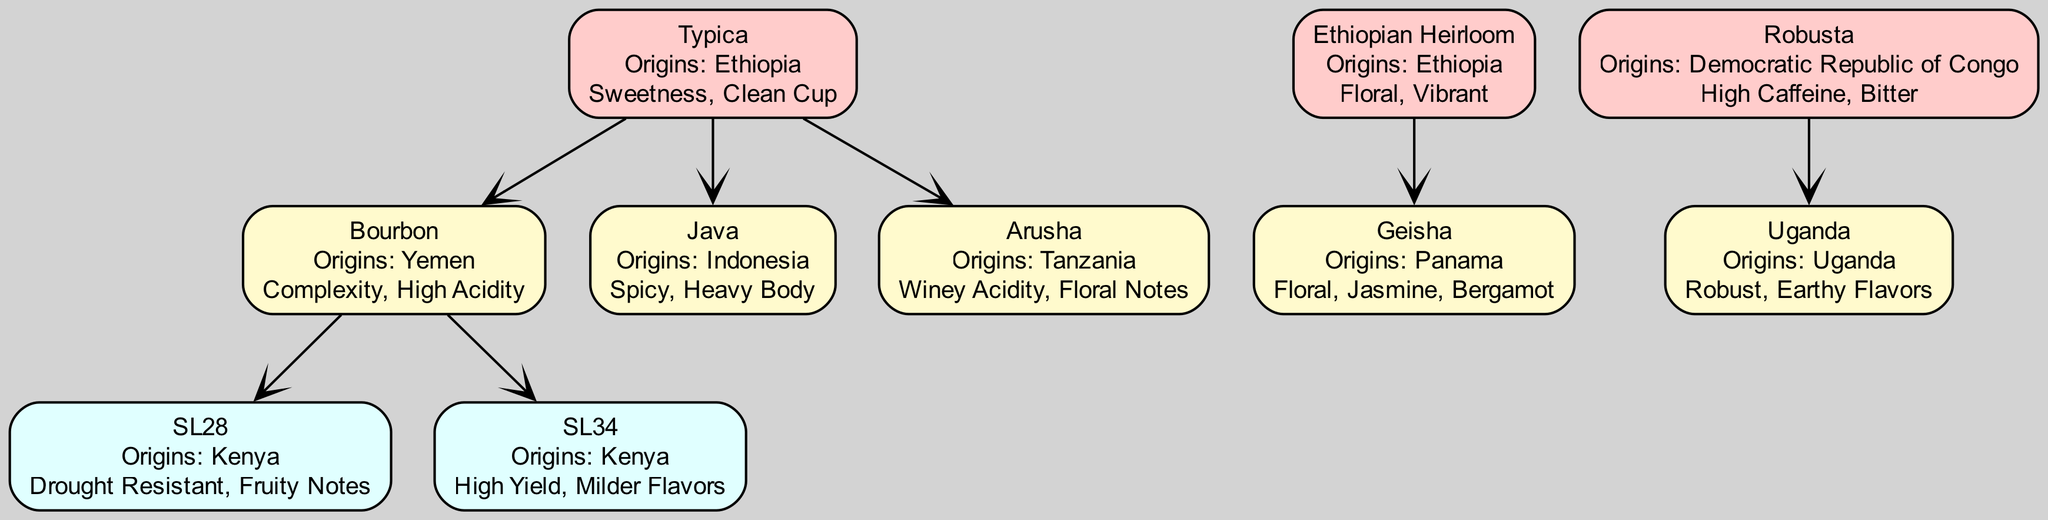What are the origins of Typica? The diagram indicates that Typica has its origins in Ethiopia, as specified directly in its node label.
Answer: Ethiopia How many descendants does Bourbon have? Looking at the Bourbon node in the diagram, it lists two descendants: SL28 and SL34, making the count of descendants two.
Answer: 2 What characteristics are associated with Geisha? The Geisha node provides specific characteristics: Floral, Jasmine, and Bergamot, which are directly described in its label.
Answer: Floral, Jasmine, Bergamot Which varietal descends from Ethiopian Heirloom? The diagram shows that the sole descendant of Ethiopian Heirloom is Geisha, indicated clearly in its branching structure.
Answer: Geisha What is the primary origin of Robusta? In the diagram, Robusta's origin is specified as being the Democratic Republic of Congo, which is shown in its corresponding node.
Answer: Democratic Republic of Congo Which varietal has the characteristic of "Drought Resistant"? The SL28 node specifically mentions Drought Resistant as one of its characteristics, allowing us to identify SL28 directly as the answer.
Answer: SL28 How many main groups of coffee varietals are depicted in the diagram? By examining the top-level nodes under 'Coffee Bean Varietals', there are three groups: Typica, Ethiopian Heirloom, and Robusta, which gives a total of three main groups.
Answer: 3 What characteristic differentiates Java from other varietals under Typica? Java is defined by its unique characteristic of being Spicy with a Heavy Body, which differentiates it from the other descendants of Typica.
Answer: Spicy, Heavy Body In which country did SL34 originate? The SL34 node states that its origins are in Kenya, and this information is part of its labeling.
Answer: Kenya 